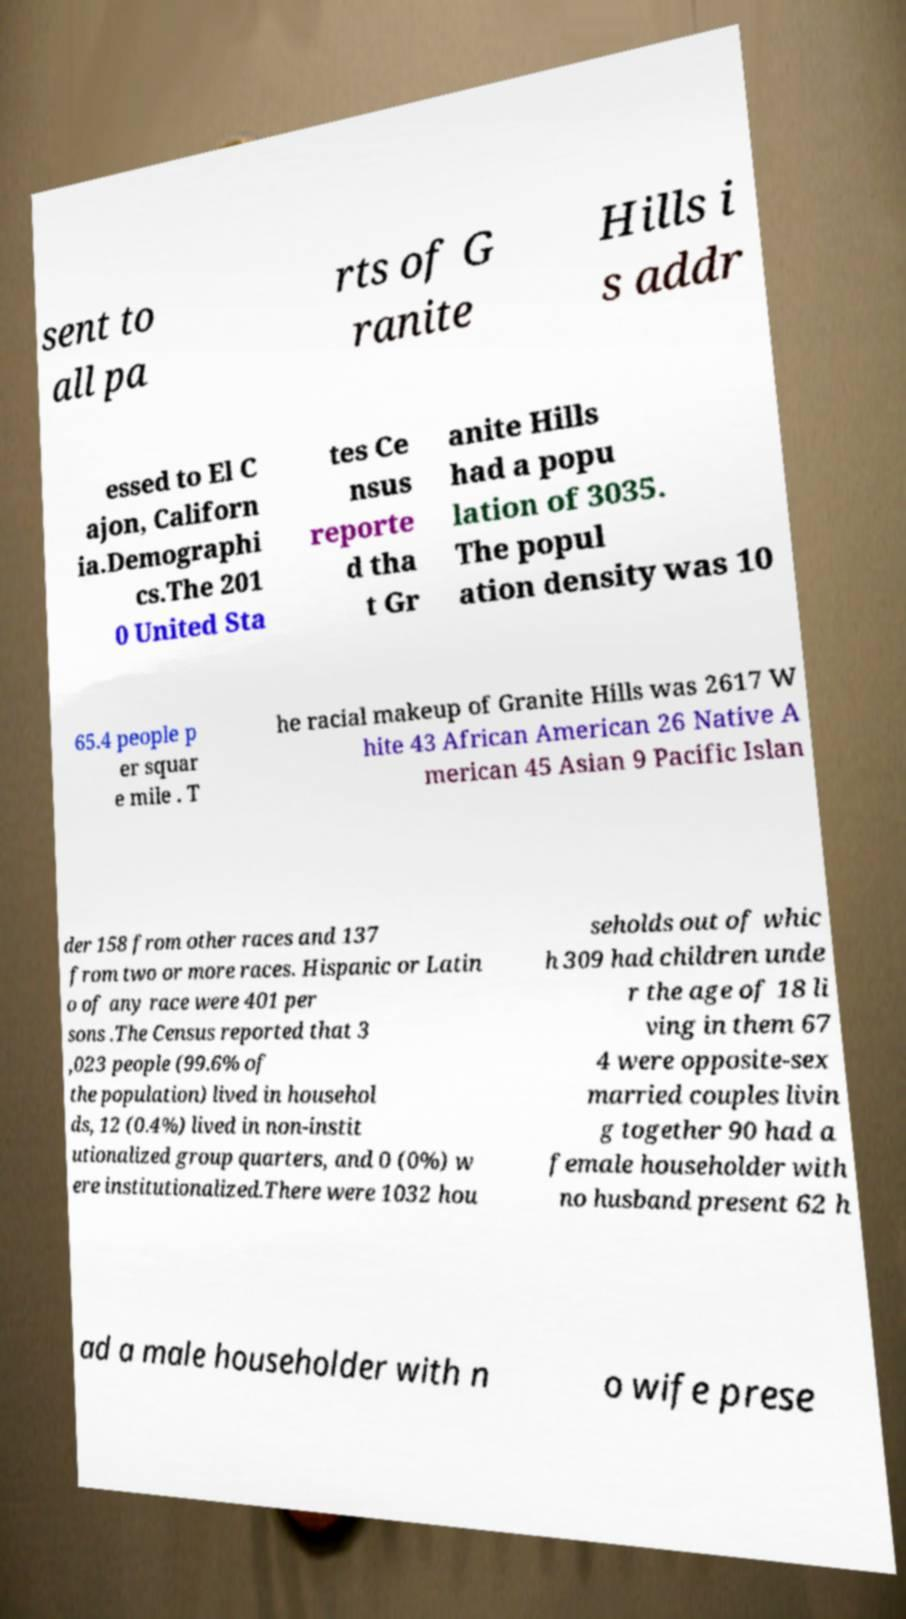Could you assist in decoding the text presented in this image and type it out clearly? sent to all pa rts of G ranite Hills i s addr essed to El C ajon, Californ ia.Demographi cs.The 201 0 United Sta tes Ce nsus reporte d tha t Gr anite Hills had a popu lation of 3035. The popul ation density was 10 65.4 people p er squar e mile . T he racial makeup of Granite Hills was 2617 W hite 43 African American 26 Native A merican 45 Asian 9 Pacific Islan der 158 from other races and 137 from two or more races. Hispanic or Latin o of any race were 401 per sons .The Census reported that 3 ,023 people (99.6% of the population) lived in househol ds, 12 (0.4%) lived in non-instit utionalized group quarters, and 0 (0%) w ere institutionalized.There were 1032 hou seholds out of whic h 309 had children unde r the age of 18 li ving in them 67 4 were opposite-sex married couples livin g together 90 had a female householder with no husband present 62 h ad a male householder with n o wife prese 